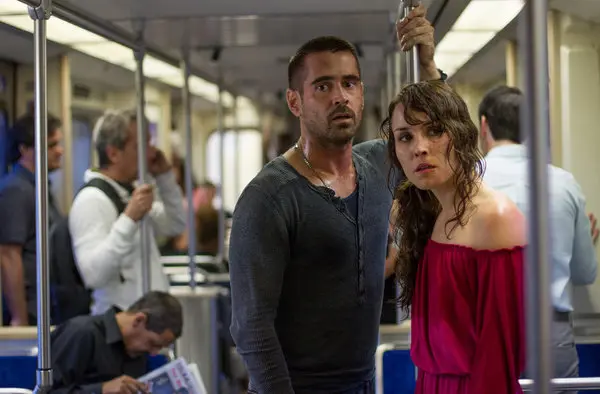Describe the overall atmosphere of the scene in this image. The atmosphere in this scene is extremely tense and charged with suspense. The dim lighting and the confined environment of the subway car amplify the feeling of claustrophobia and urgency. The subdued colors and the serious expressions of the main characters, contrasted with the blurred, indifferent faces of the other passengers, create a sense of isolation and pressurizing focus on the main conflict or concern shared by Noomi Rapace and Colin Farrell's characters. Could you provide a detailed analysis of how the background elements contribute to the narrative tone? The background elements play a significant role in enhancing the narrative tone of this image. The subway car itself, being a public but enclosed space, adds to the feeling of entrapment and urgency. The blurred figures of other passengers create contrast by distancing them from the main characters' intense personal crisis, emphasizing their isolation even in a crowded place. This blurring effect also directs the viewer's attention sharply towards Noomi Rapace and Colin Farrell, spotlighting their emotional states. The presence of passengers absorbed in mundane activities, like reading newspapers and looking out windows, underscores the disconnect between the normalcy of everyday life and the extraordinary tension faced by the protagonists. This juxtaposition deepens the viewer's sense of empathy and suspense about the characters' predicament. 